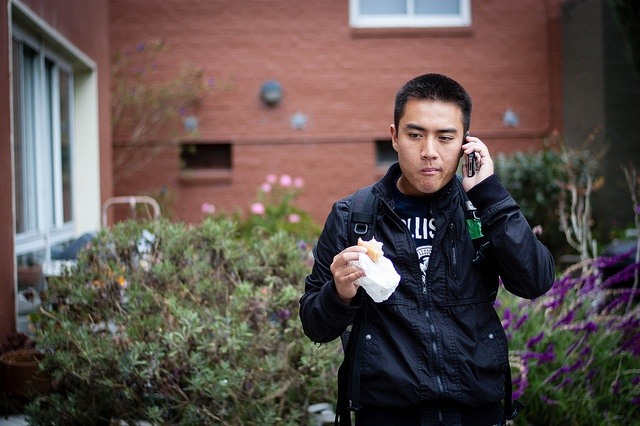Describe the objects in this image and their specific colors. I can see people in black, navy, lightgray, and brown tones, backpack in black, navy, gray, and teal tones, sandwich in black, white, darkgray, tan, and lightgray tones, donut in black, white, and tan tones, and sandwich in black, white, tan, and navy tones in this image. 